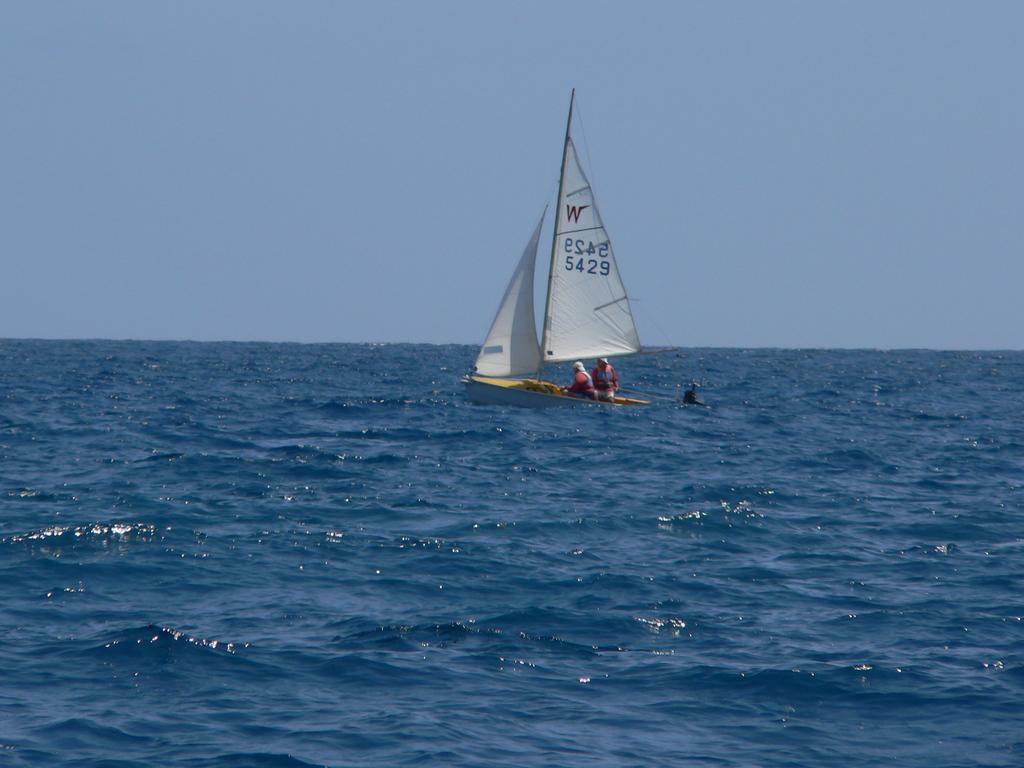In one or two sentences, can you explain what this image depicts? In this picture we can see two people on a boat and this boat is on water and in the background we can see the sky. 